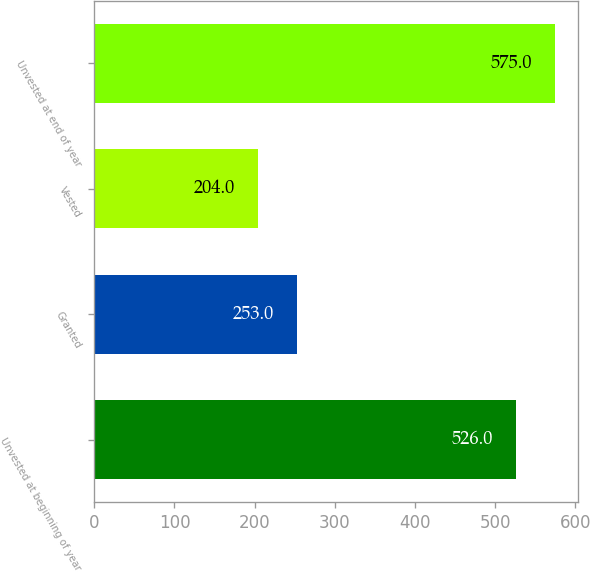Convert chart to OTSL. <chart><loc_0><loc_0><loc_500><loc_500><bar_chart><fcel>Unvested at beginning of year<fcel>Granted<fcel>Vested<fcel>Unvested at end of year<nl><fcel>526<fcel>253<fcel>204<fcel>575<nl></chart> 